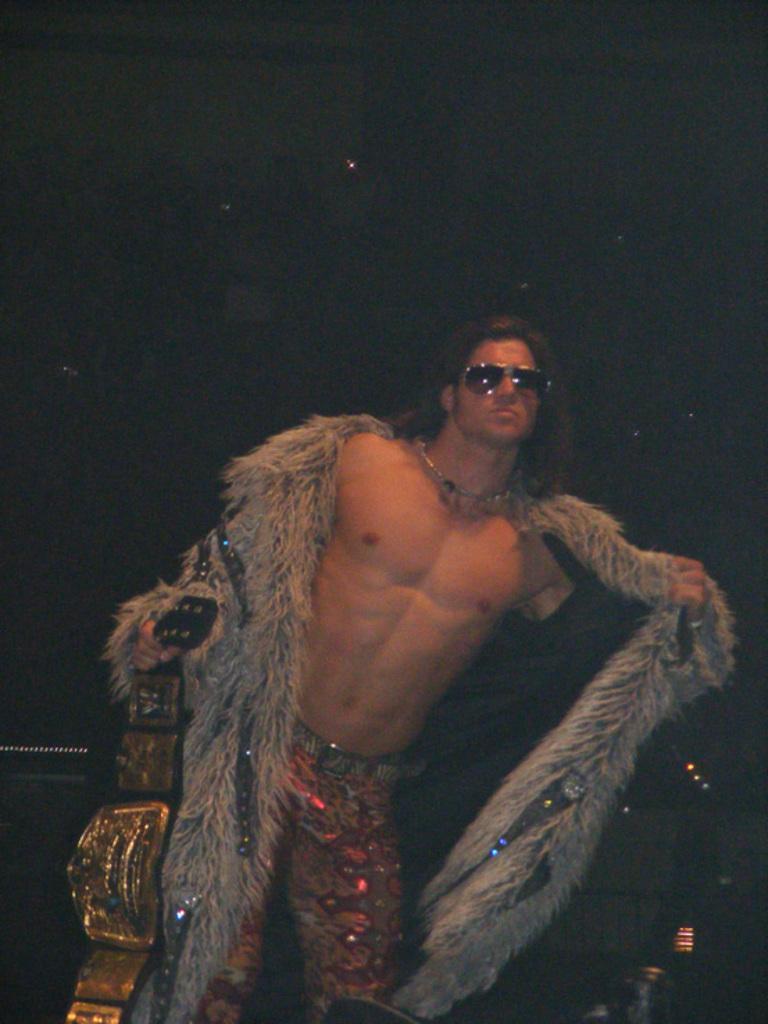Could you give a brief overview of what you see in this image? In the foreground of this picture, there is a man standing and holding a gold belt in his hand and the background is dark. 